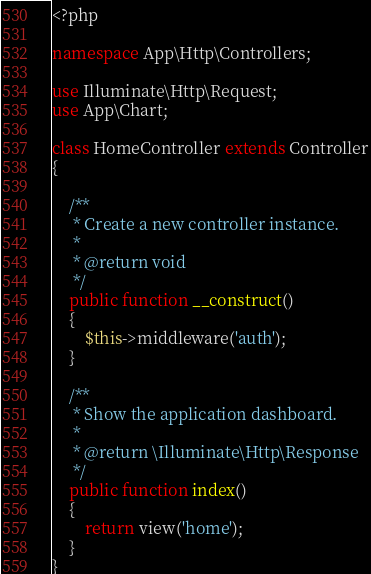Convert code to text. <code><loc_0><loc_0><loc_500><loc_500><_PHP_><?php

namespace App\Http\Controllers;

use Illuminate\Http\Request;
use App\Chart;

class HomeController extends Controller
{

    /**
     * Create a new controller instance.
     *
     * @return void
     */
    public function __construct()
    {
        $this->middleware('auth');
    }

    /**
     * Show the application dashboard.
     *
     * @return \Illuminate\Http\Response
     */
    public function index()
    {
        return view('home');
    }
}
</code> 